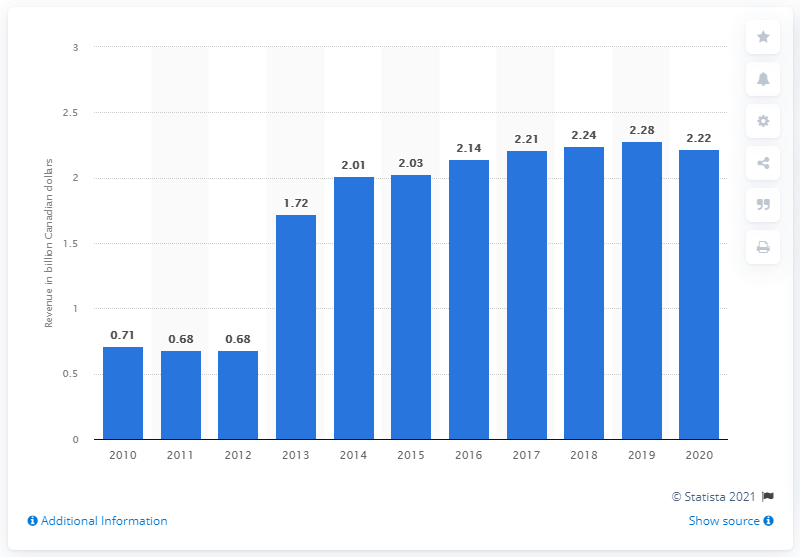Point out several critical features in this image. Leon's Furniture Limited's revenue in Canada in the previous year was CAD 2.28 million. In 2020, Leon's Furniture Limited generated a total of CAD 2.22 million in revenue in Canada. 